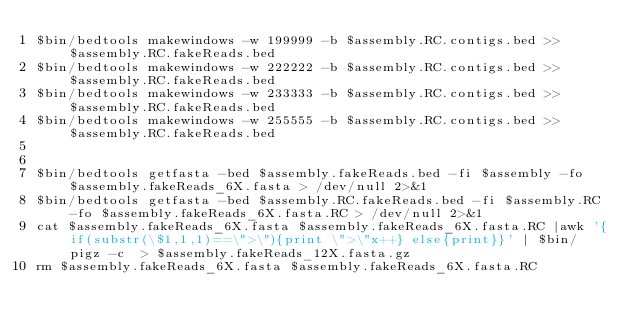Convert code to text. <code><loc_0><loc_0><loc_500><loc_500><_Perl_>$bin/bedtools makewindows -w 199999 -b $assembly.RC.contigs.bed >> $assembly.RC.fakeReads.bed
$bin/bedtools makewindows -w 222222 -b $assembly.RC.contigs.bed >> $assembly.RC.fakeReads.bed
$bin/bedtools makewindows -w 233333 -b $assembly.RC.contigs.bed >> $assembly.RC.fakeReads.bed
$bin/bedtools makewindows -w 255555 -b $assembly.RC.contigs.bed >> $assembly.RC.fakeReads.bed


$bin/bedtools getfasta -bed $assembly.fakeReads.bed -fi $assembly -fo $assembly.fakeReads_6X.fasta > /dev/null 2>&1
$bin/bedtools getfasta -bed $assembly.RC.fakeReads.bed -fi $assembly.RC -fo $assembly.fakeReads_6X.fasta.RC > /dev/null 2>&1
cat $assembly.fakeReads_6X.fasta $assembly.fakeReads_6X.fasta.RC |awk '{if(substr(\$1,1,1)==\">\"){print \">\"x++} else{print}}' | $bin/pigz -c  > $assembly.fakeReads_12X.fasta.gz
rm $assembly.fakeReads_6X.fasta $assembly.fakeReads_6X.fasta.RC
</code> 